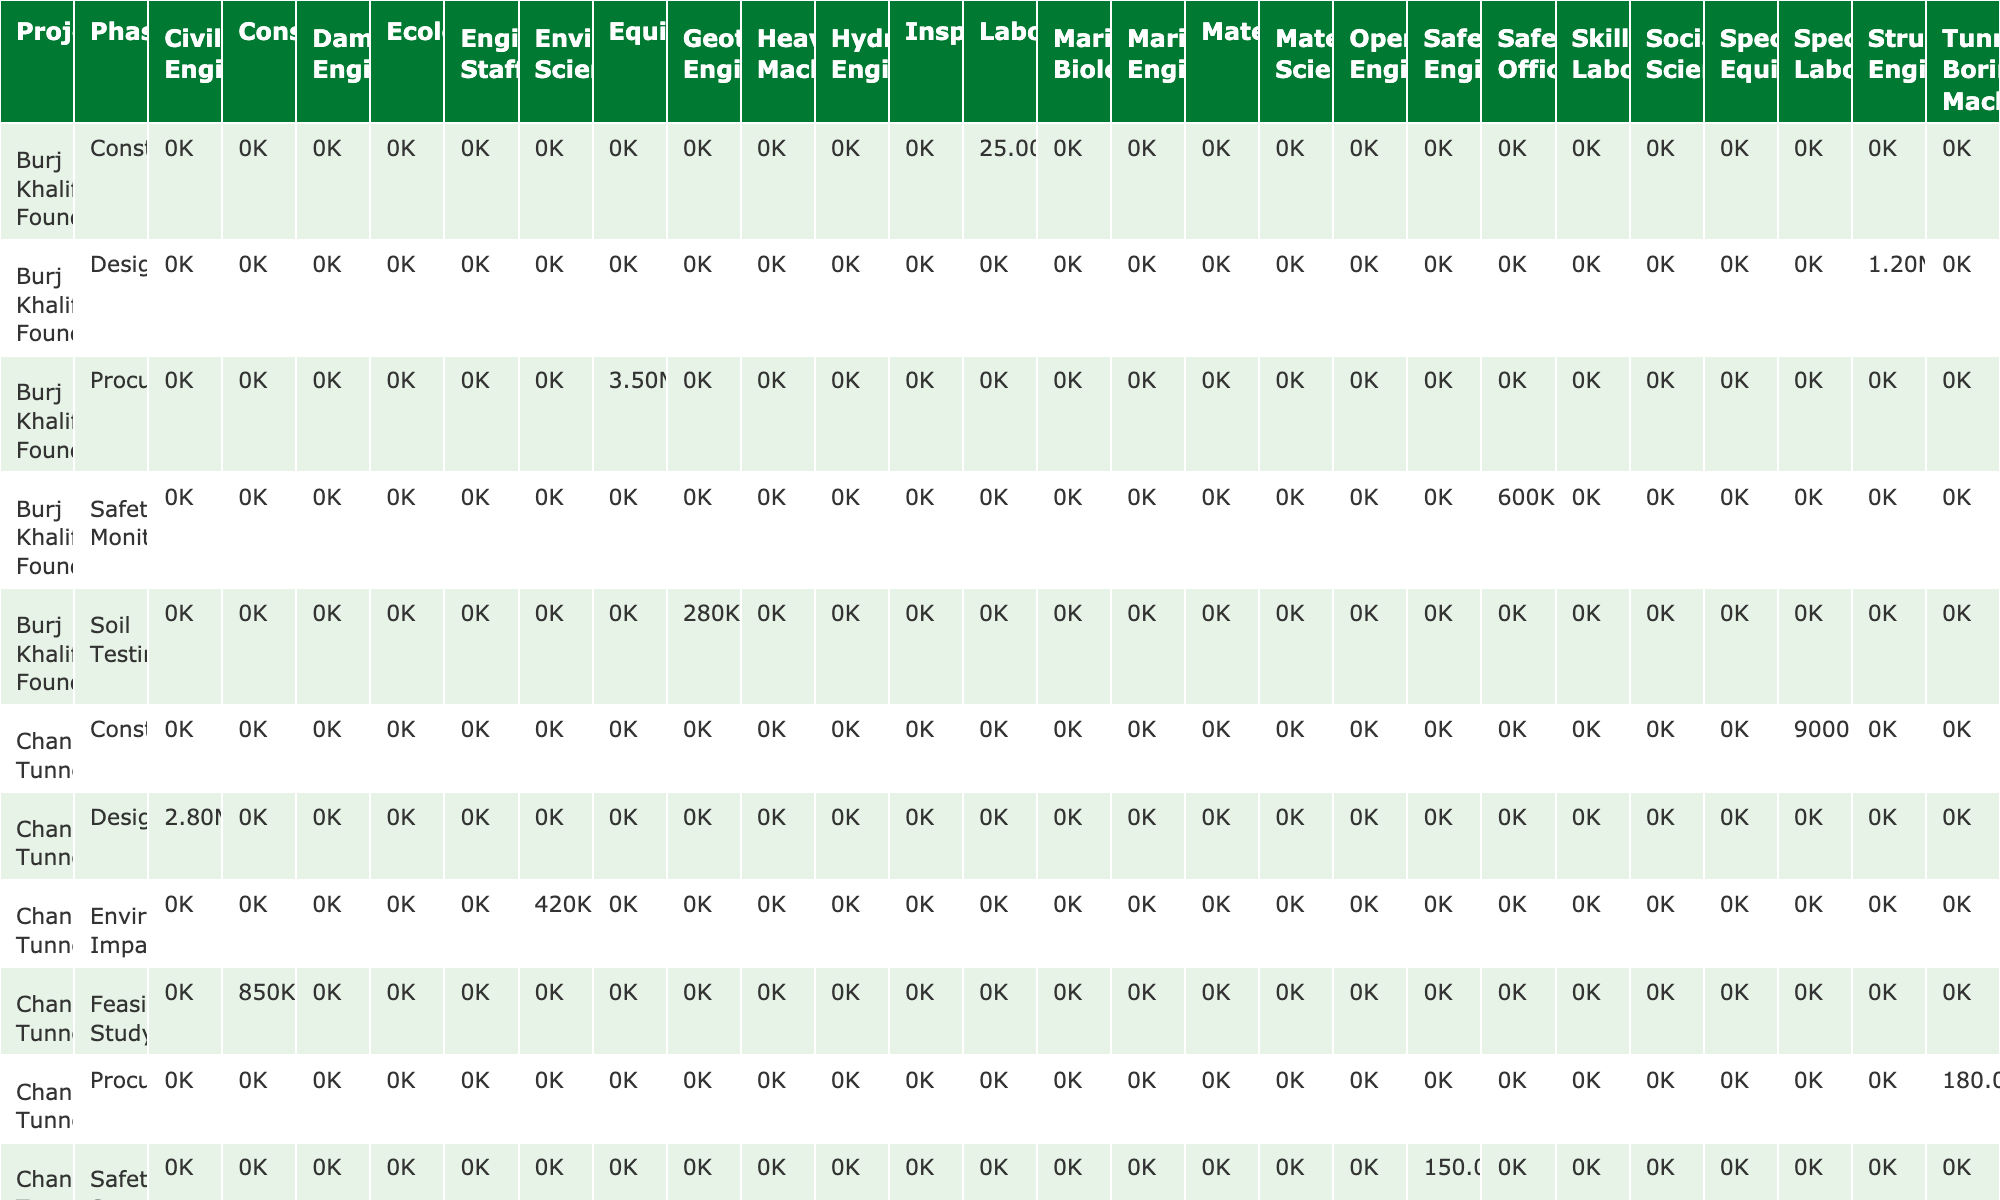What is the total cost of the procurement phase for the Golden Gate Bridge Retrofit project? The procurement phase cost for the Golden Gate Bridge Retrofit project is shown directly in the table as $2,300,000.
Answer: $2.3M Which project has the highest cost in the construction phase? In the construction phase, the Channel Tunnel has the highest cost listed at $9,000,000,000.
Answer: Channel Tunnel How many weeks are spent in total on phases that require engineering staff across all projects? From the table, the Golden Gate Bridge Retrofit has 12 weeks for planning with engineering staff. No other projects list engineering staff in mentioned phases. Thus, the total is 12 weeks.
Answer: 12 weeks Is the risk level for the Panama Canal Expansion project in the construction phase assessed as extreme? Looking at the table, it shows that the risk level for the construction phase of the Panama Canal Expansion is classified as very high, not extreme.
Answer: No What is the average cost for the design phase across all projects? The costs for the design phase are: Golden Gate Bridge Retrofit at $980,000, Burj Khalifa Foundation at $1,200,000, Channel Tunnel at $2,800,000, Three Gorges Dam at $3,500,000, and Panama Canal Expansion at $2,500,000. Summing these gives $10,980,000, and dividing by 5 projects gives an average of $2,196,000.
Answer: $2.20M Which project has the longest duration in the quality control phase? The Golden Gate Bridge Retrofit has 120 weeks listed for the quality control phase, which is longer than any other project in that phase.
Answer: Golden Gate Bridge Retrofit How much more cost is needed in the construction phase for the Three Gorges Dam compared to the Golden Gate Bridge Retrofit? The construction cost for the Three Gorges Dam is $22,500,000,000 and for the Golden Gate Bridge Retrofit is $15,000,000. The difference is $22,500,000,000 - $15,000,000 which equals $22,485,000,000.
Answer: $22,485M Are there any phases in any projects that require heavy machinery? The table indicates that only the Three Gorges Dam has a phase (construction) that specifically lists heavy machinery as a resource type.
Answer: Yes What is the total number of weeks dedicated to safety systems in the Channel Tunnel project? The table shows that 280 weeks are dedicated to safety systems in the Channel Tunnel project, which is the only entry for safety systems so the total is simply that value.
Answer: 280 weeks 